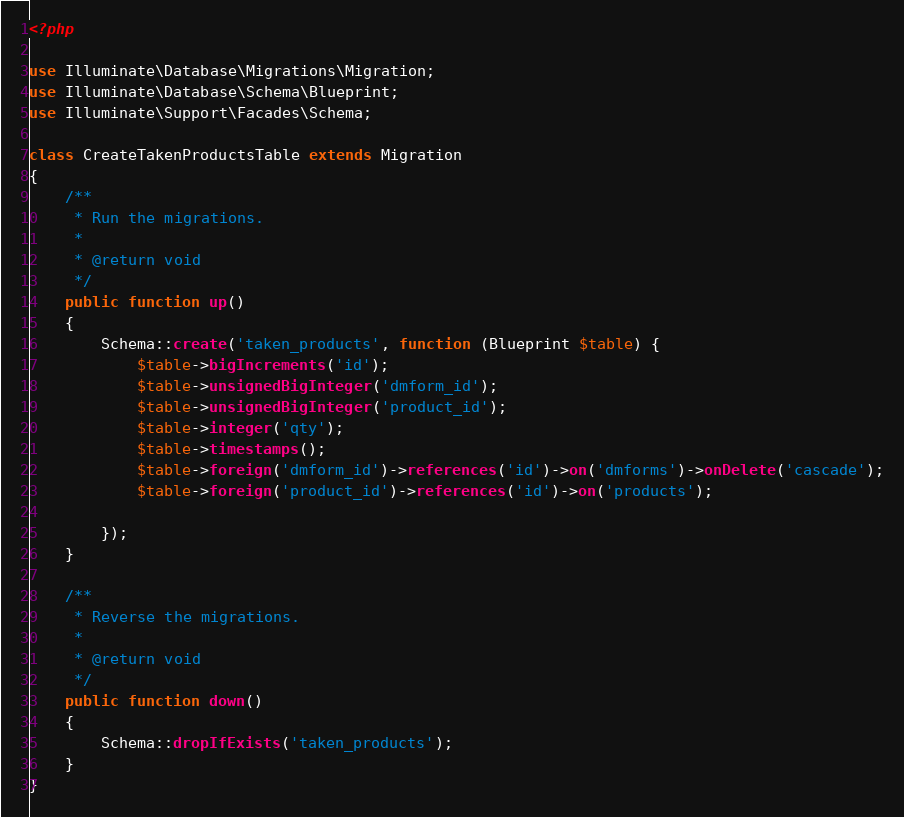<code> <loc_0><loc_0><loc_500><loc_500><_PHP_><?php

use Illuminate\Database\Migrations\Migration;
use Illuminate\Database\Schema\Blueprint;
use Illuminate\Support\Facades\Schema;

class CreateTakenProductsTable extends Migration
{
    /**
     * Run the migrations.
     *
     * @return void
     */
    public function up()
    {
        Schema::create('taken_products', function (Blueprint $table) {
            $table->bigIncrements('id');
            $table->unsignedBigInteger('dmform_id');
            $table->unsignedBigInteger('product_id');
            $table->integer('qty');
            $table->timestamps();
            $table->foreign('dmform_id')->references('id')->on('dmforms')->onDelete('cascade');
            $table->foreign('product_id')->references('id')->on('products');
        
        });
    }

    /**
     * Reverse the migrations.
     *
     * @return void
     */
    public function down()
    {
        Schema::dropIfExists('taken_products');
    }
}
</code> 